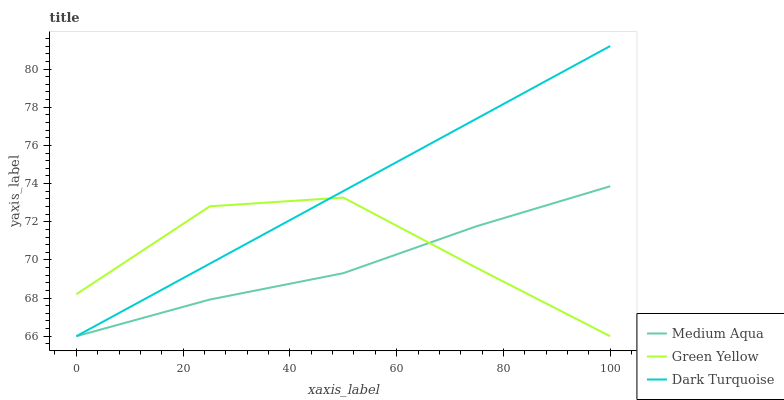Does Green Yellow have the minimum area under the curve?
Answer yes or no. No. Does Green Yellow have the maximum area under the curve?
Answer yes or no. No. Is Medium Aqua the smoothest?
Answer yes or no. No. Is Medium Aqua the roughest?
Answer yes or no. No. Does Medium Aqua have the highest value?
Answer yes or no. No. 